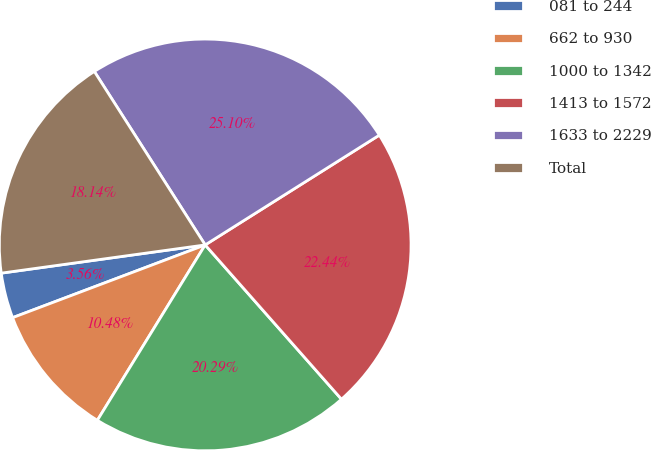Convert chart. <chart><loc_0><loc_0><loc_500><loc_500><pie_chart><fcel>081 to 244<fcel>662 to 930<fcel>1000 to 1342<fcel>1413 to 1572<fcel>1633 to 2229<fcel>Total<nl><fcel>3.56%<fcel>10.48%<fcel>20.29%<fcel>22.44%<fcel>25.1%<fcel>18.14%<nl></chart> 